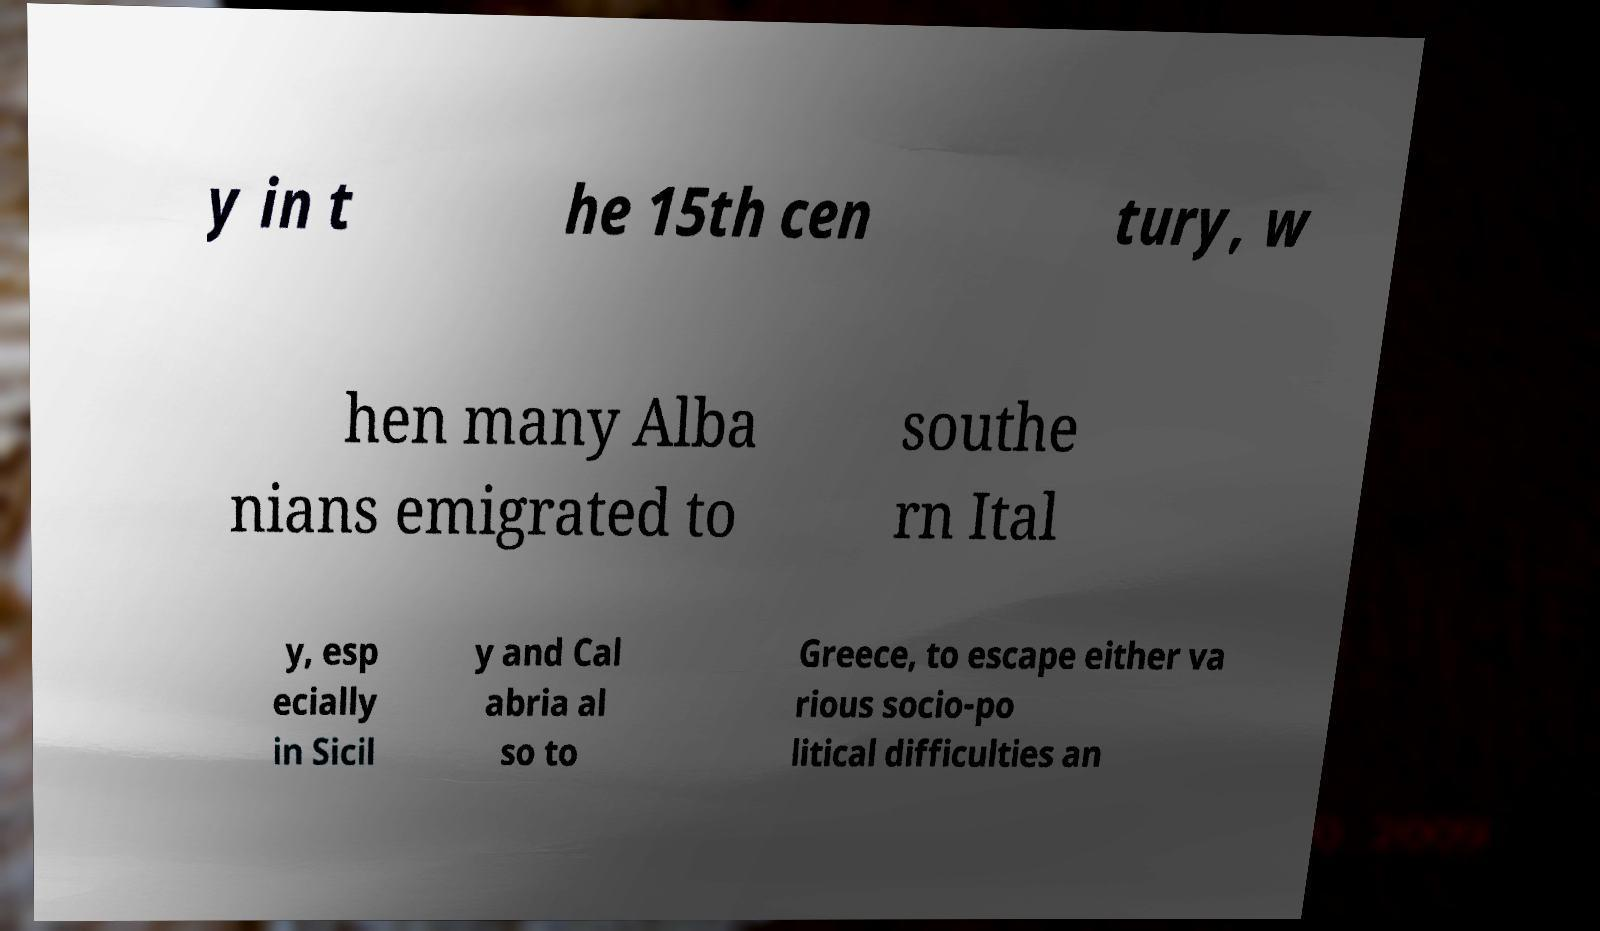Can you accurately transcribe the text from the provided image for me? y in t he 15th cen tury, w hen many Alba nians emigrated to southe rn Ital y, esp ecially in Sicil y and Cal abria al so to Greece, to escape either va rious socio-po litical difficulties an 